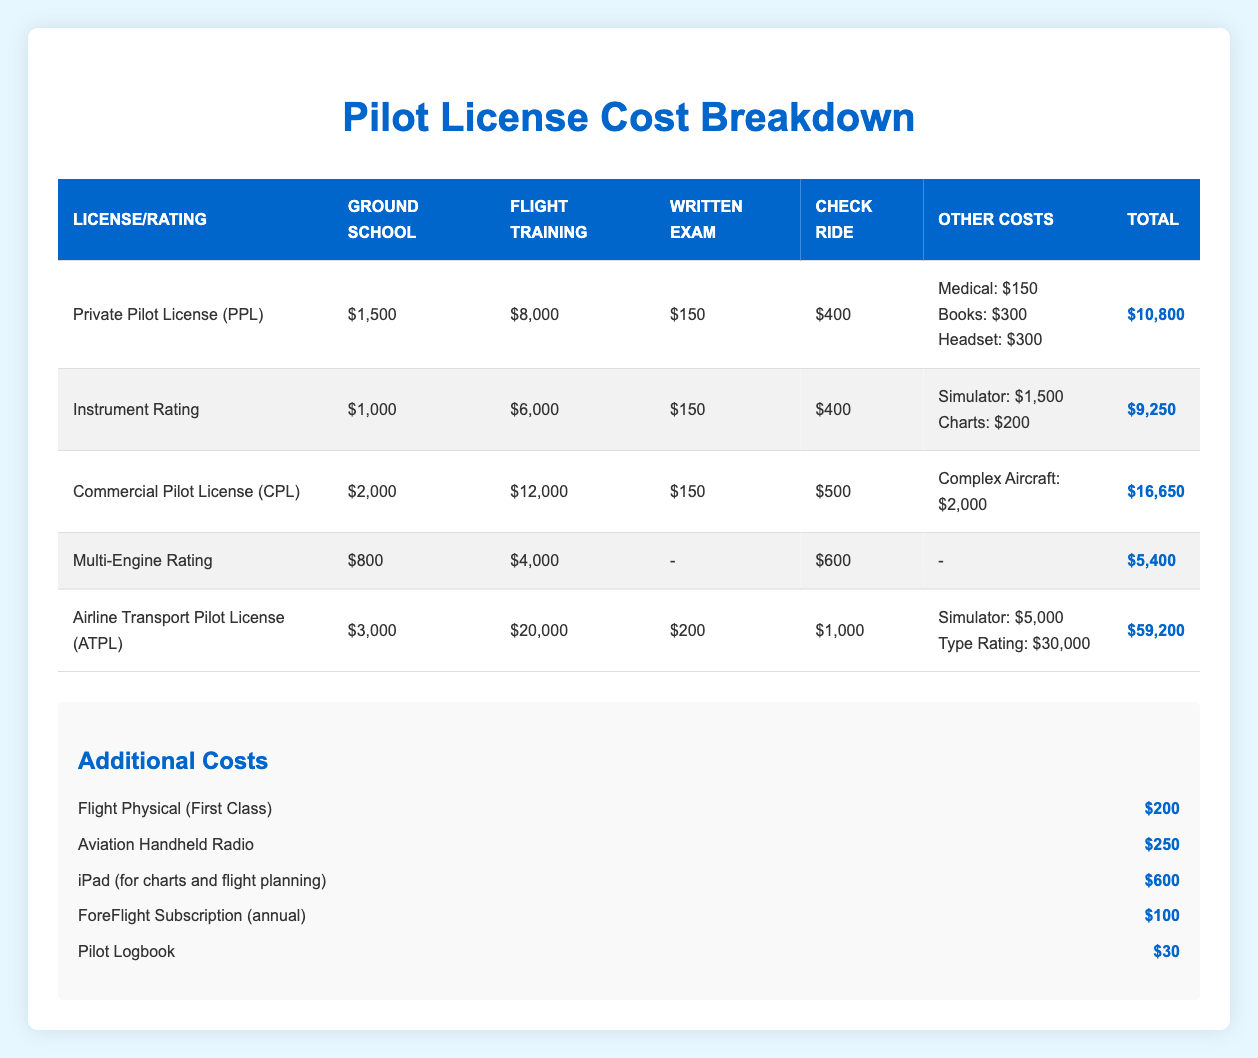What is the total cost of obtaining a Private Pilot License (PPL)? The total cost for obtaining a Private Pilot License (PPL) is listed in the table as $10,800.
Answer: $10,800 How much does the flight training for an Airline Transport Pilot License (ATPL) cost? The flight training cost for an Airline Transport Pilot License (ATPL) is given as $20,000 in the table.
Answer: $20,000 Which license has the lowest total cost? The total costs of the licenses are: PPL - $10,800, Instrument Rating - $9,250, CPL - $16,650, Multi-Engine Rating - $5,400, and ATPL - $59,200. The Multi-Engine Rating has the lowest total cost at $5,400.
Answer: Multi-Engine Rating How much more does it cost to obtain a Commercial Pilot License (CPL) compared to an Instrument Rating? The cost for CPL is $16,650 and for Instrument Rating is $9,250. To find the difference: 16,650 - 9,250 = 7,400. Therefore, it costs $7,400 more for CPL.
Answer: $7,400 Is the total cost of the Instrument Rating less than $10,000? The total cost of the Instrument Rating is $9,250, which is indeed less than $10,000, so the answer is yes.
Answer: Yes What is the combined total cost of obtaining both a Private Pilot License (PPL) and an Instrument Rating? The total cost for PPL is $10,800 and for Instrument Rating is $9,250. Adding these together: 10,800 + 9,250 = 20,050. Therefore, the combined total cost is $20,050.
Answer: $20,050 What percentage of the total cost of an Airline Transport Pilot License (ATPL) does the cost for the ground school represent? The ground school cost for ATPL is $3,000 and the total cost is $59,200. To find the percentage, divide the ground school cost by the total cost and multiply by 100: (3,000 / 59,200) * 100 ≈ 5.06%.
Answer: Approximately 5.06% How much do written exams cost across all licenses combined? The written exam costs are: PPL - $150, Instrument Rating - $150, CPL - $150, Multi-Engine Rating - not applicable, ATPL - $200. Adding the applicable costs gives: 150 + 150 + 150 + 200 = 650. Therefore, the total cost for written exams is $650.
Answer: $650 What additional costs must be accounted for when planning to become a pilot? The additional costs listed include: Flight Physical ($200), Aviation Handheld Radio ($250), iPad ($600), ForeFlight Subscription ($100), and Pilot Logbook ($30). Summing these gives: 200 + 250 + 600 + 100 + 30 = 1,180, so the additional costs total $1,180.
Answer: $1,180 